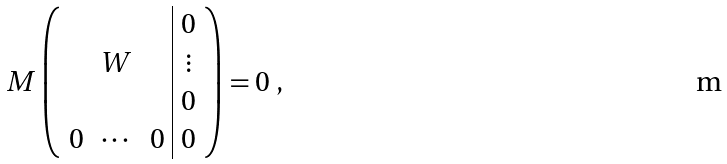<formula> <loc_0><loc_0><loc_500><loc_500>M \left ( \begin{array} { c c c | c } & & & 0 \\ & W & & \vdots \\ & & & 0 \\ 0 & \cdots & 0 & 0 \end{array} \right ) = 0 \ ,</formula> 